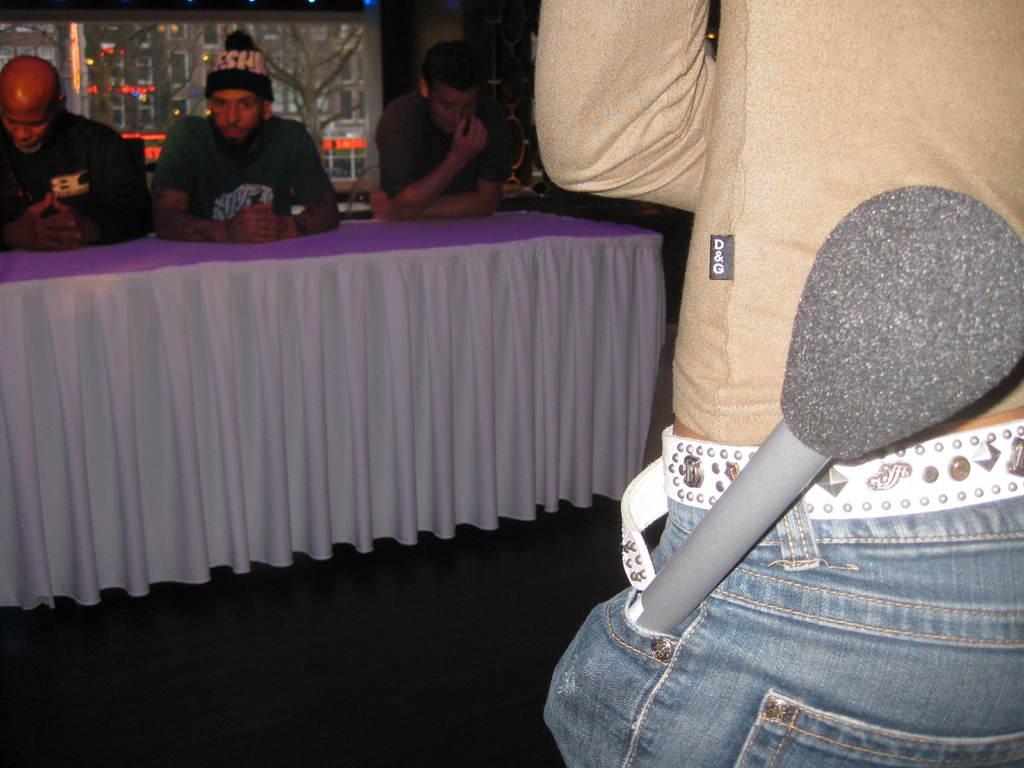Describe this image in one or two sentences. In this image there are a few people sitting on the chairs at the table. There is a cloth spread on the table. To the right there is a person standing. There is a microphone in the pocket. In the background there is a glass wall. Outside the wall there are buildings and trees. 